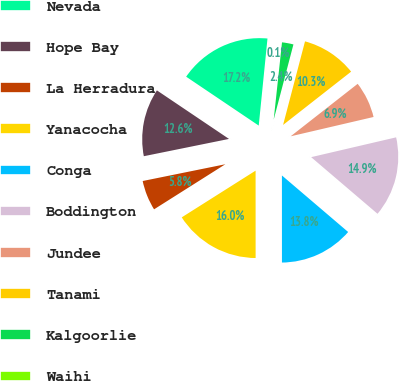<chart> <loc_0><loc_0><loc_500><loc_500><pie_chart><fcel>Nevada<fcel>Hope Bay<fcel>La Herradura<fcel>Yanacocha<fcel>Conga<fcel>Boddington<fcel>Jundee<fcel>Tanami<fcel>Kalgoorlie<fcel>Waihi<nl><fcel>17.16%<fcel>12.62%<fcel>5.79%<fcel>16.03%<fcel>13.75%<fcel>14.89%<fcel>6.93%<fcel>10.34%<fcel>2.38%<fcel>0.11%<nl></chart> 